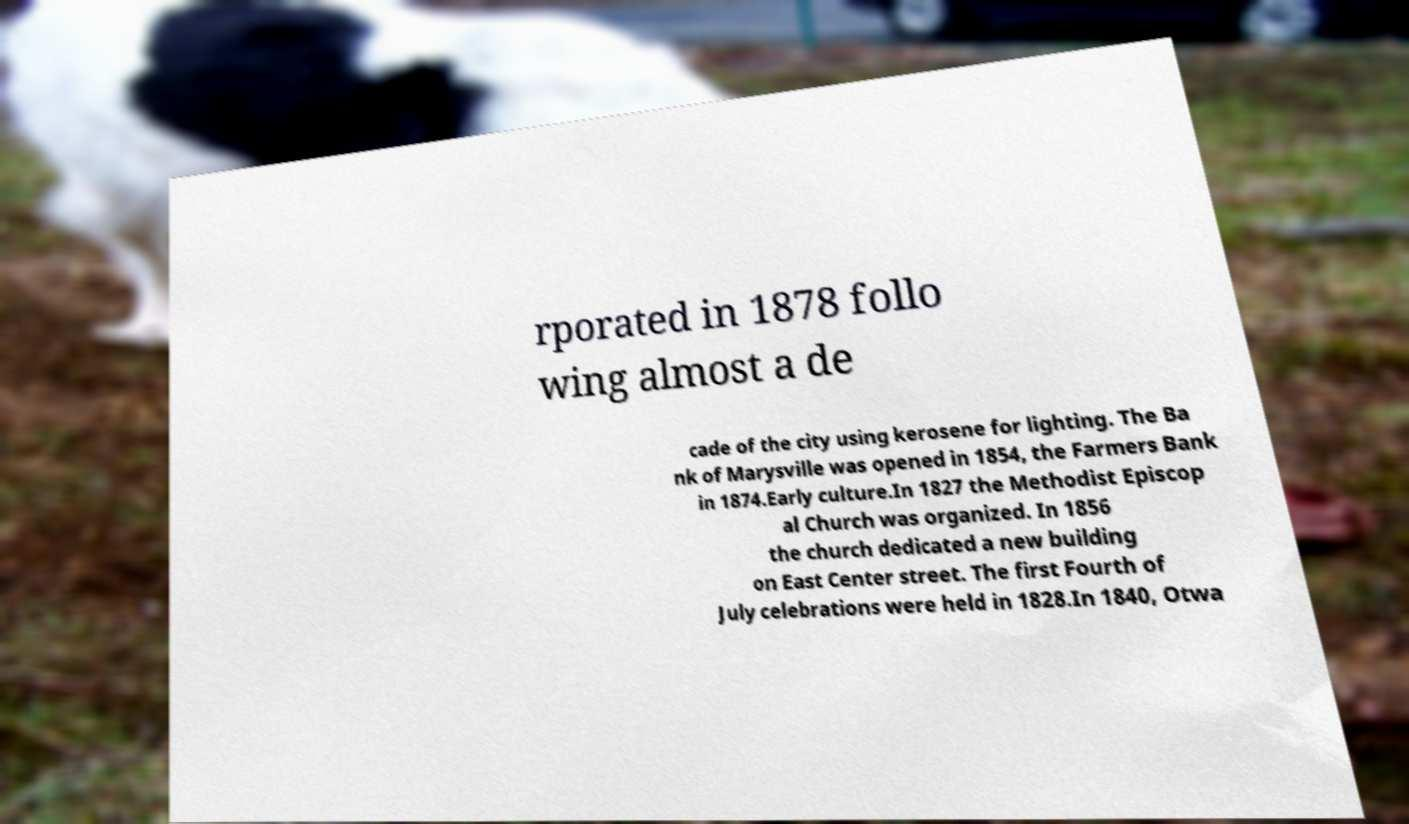Could you assist in decoding the text presented in this image and type it out clearly? rporated in 1878 follo wing almost a de cade of the city using kerosene for lighting. The Ba nk of Marysville was opened in 1854, the Farmers Bank in 1874.Early culture.In 1827 the Methodist Episcop al Church was organized. In 1856 the church dedicated a new building on East Center street. The first Fourth of July celebrations were held in 1828.In 1840, Otwa 